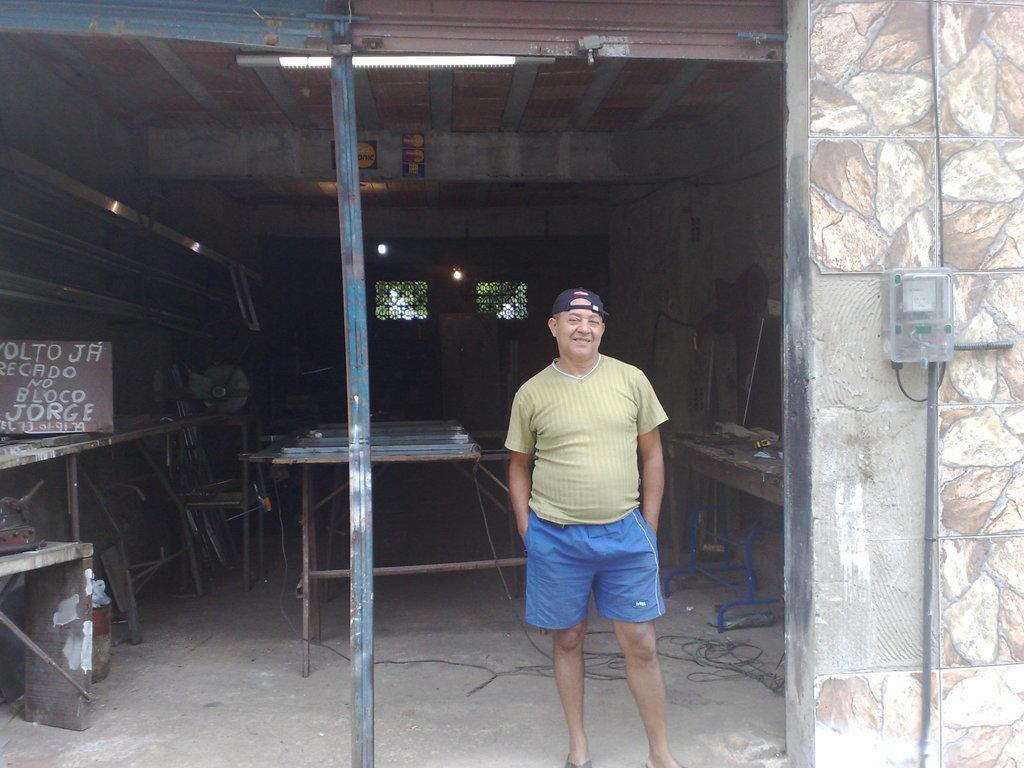<image>
Write a terse but informative summary of the picture. Man standing in an area with a sign which says "JORGE" on it. 